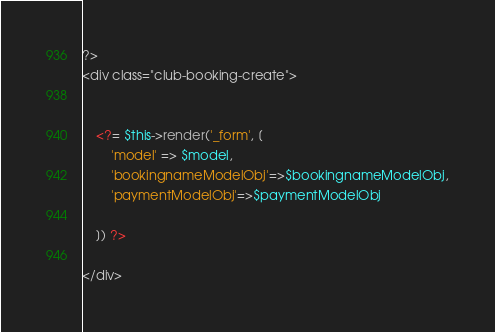Convert code to text. <code><loc_0><loc_0><loc_500><loc_500><_PHP_>?>
<div class="club-booking-create">

  
    <?= $this->render('_form', [
        'model' => $model,
        'bookingnameModelObj'=>$bookingnameModelObj,
        'paymentModelObj'=>$paymentModelObj
            
    ]) ?>

</div>
</code> 